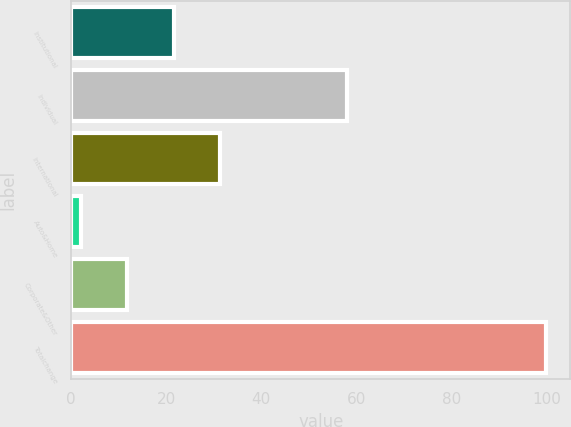Convert chart. <chart><loc_0><loc_0><loc_500><loc_500><bar_chart><fcel>Institutional<fcel>Individual<fcel>International<fcel>Auto&Home<fcel>Corporate&Other<fcel>Totalchange<nl><fcel>21.6<fcel>58<fcel>31.4<fcel>2<fcel>11.8<fcel>100<nl></chart> 